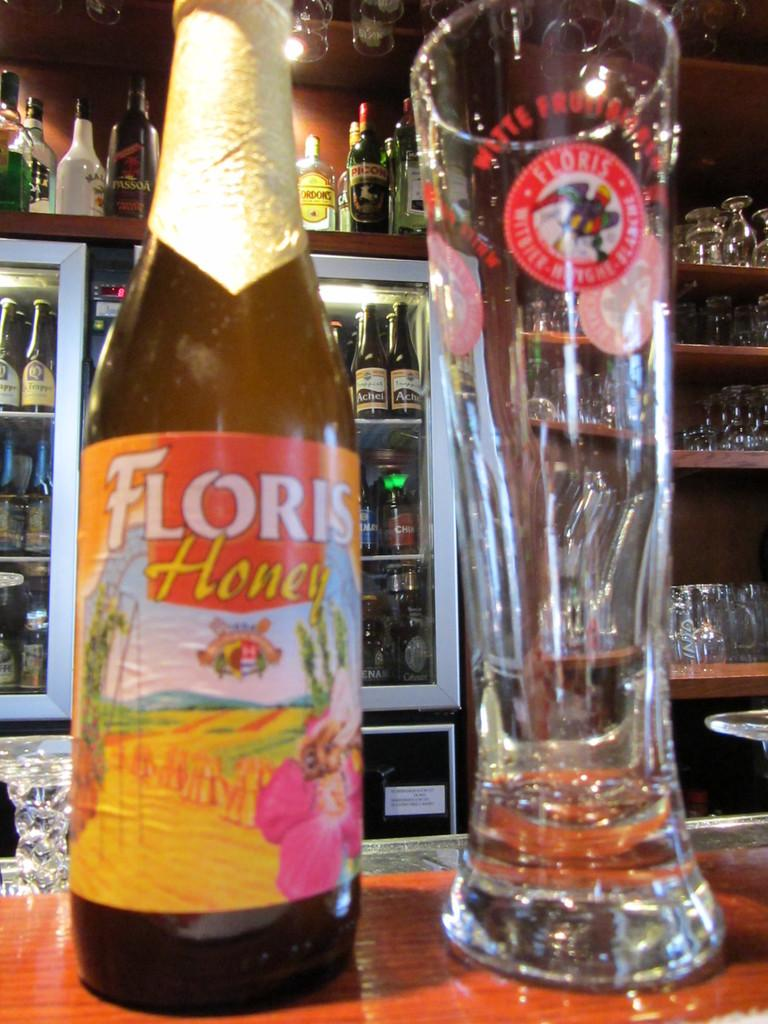<image>
Describe the image concisely. Closeup photo of a bar top with floris honey and an empty glass and more drinks in the background. 